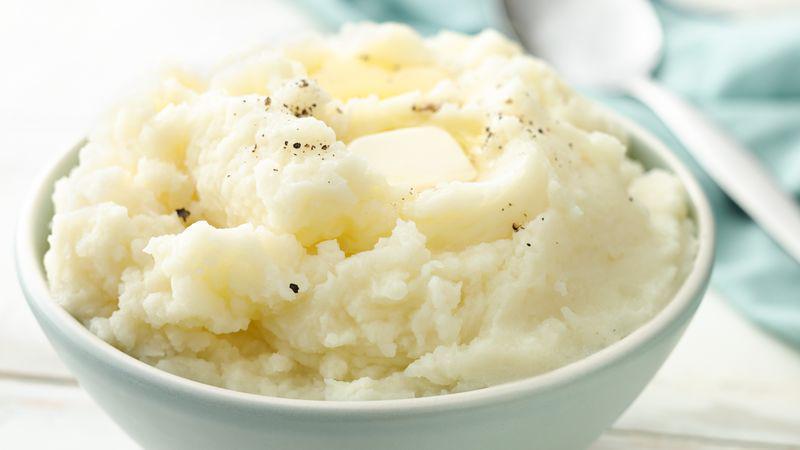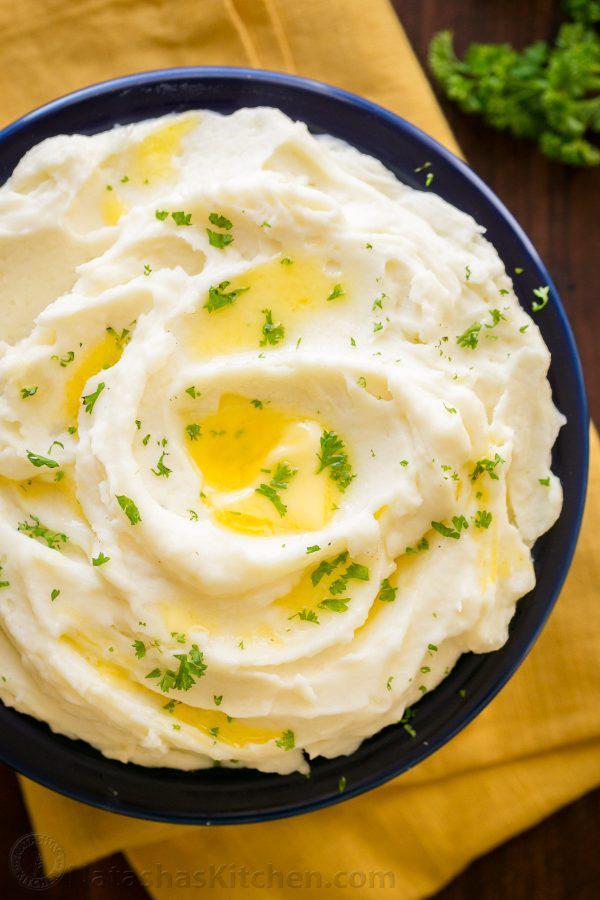The first image is the image on the left, the second image is the image on the right. Examine the images to the left and right. Is the description "A metal kitchen utinsil is sitting in a bowl of potatoes." accurate? Answer yes or no. No. The first image is the image on the left, the second image is the image on the right. For the images displayed, is the sentence "An image shows a bowl of potatoes with a metal potato masher sticking out." factually correct? Answer yes or no. No. 